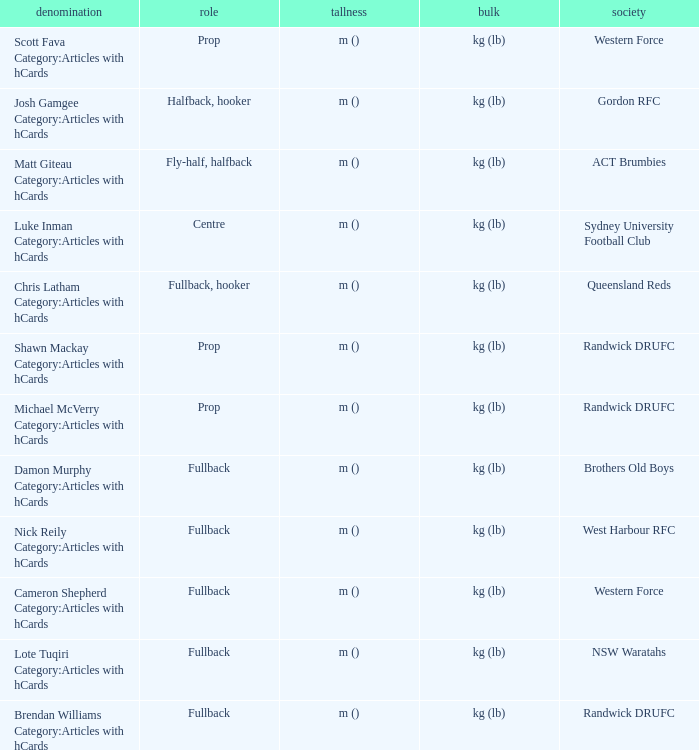What is the name when the position is centre? Luke Inman Category:Articles with hCards. 